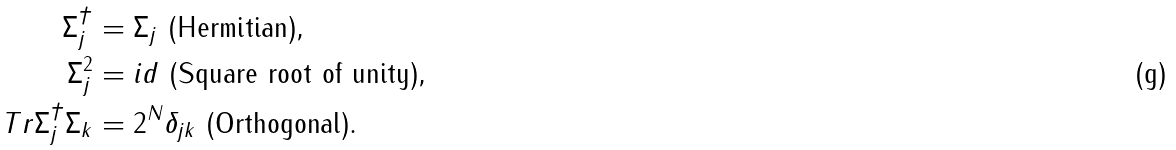<formula> <loc_0><loc_0><loc_500><loc_500>\Sigma _ { j } ^ { \dagger } & = \Sigma _ { j } \text { (Hermitian),} \\ \Sigma _ { j } ^ { 2 } & = i d \text { (Square root of unity),} \\ T r \Sigma _ { j } ^ { \dagger } \Sigma _ { k } & = 2 ^ { N } \delta _ { j k } \text { (Orthogonal).}</formula> 